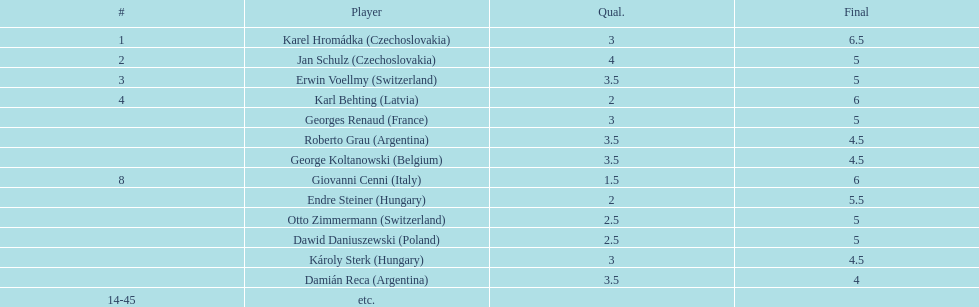Did the duo of participants from hungary accumulate greater or lesser collective points than the duo from argentina? Less. 